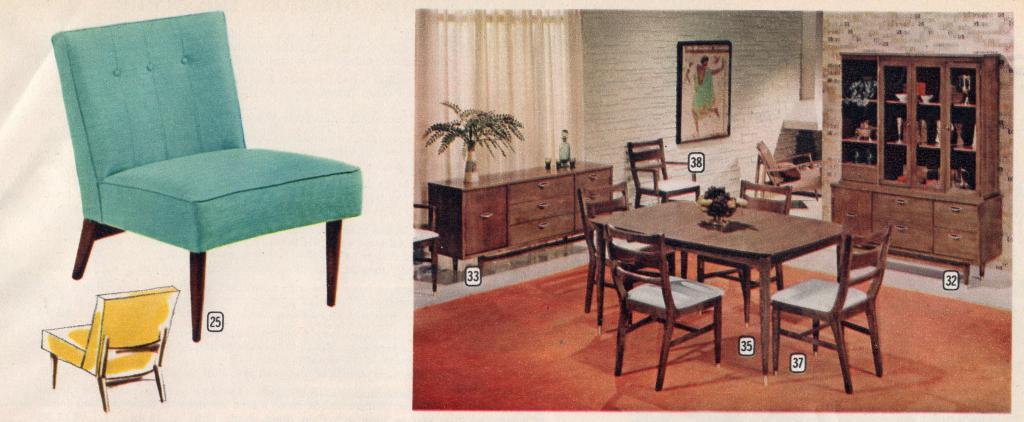Please provide a concise description of this image. In this Image I see lot of chairs, table over here, a drawer, cabinet, curtain and a photo frame on the wall. 